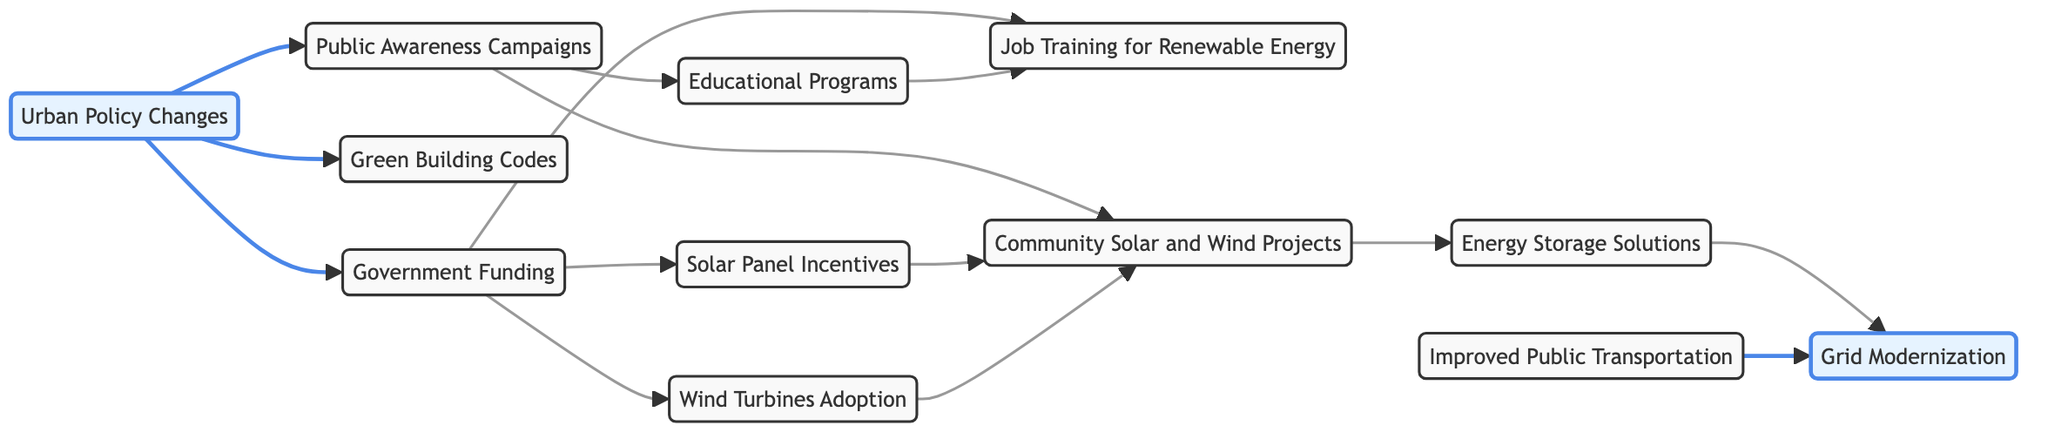What are the primary nodes in the diagram? The primary nodes are the main concepts linked within the directed graph. In this case, they include Urban Policy Changes, Public Awareness Campaigns, Solar Panel Incentives, Wind Turbines Adoption, Green Building Codes, Government Funding, Educational Programs, Job Training for Renewable Energy, Community Solar and Wind Projects, Improved Public Transportation, Energy Storage Solutions, and Grid Modernization.
Answer: Urban Policy Changes, Public Awareness Campaigns, Solar Panel Incentives, Wind Turbines Adoption, Green Building Codes, Government Funding, Educational Programs, Job Training for Renewable Energy, Community Solar and Wind Projects, Improved Public Transportation, Energy Storage Solutions, Grid Modernization How many edges are present in the graph? Edges in a directed graph are the connections between nodes. By counting each connection shown, the total number of edges in this diagram comes out to 13.
Answer: 13 Which node is influenced directly by Urban Policy Changes? Urban Policy Changes directly influences three other nodes in the graph: Public Awareness Campaigns, Green Building Codes, and Government Funding. To find the answer, we look for the nodes that are connected with an outgoing arrow from Urban Policy Changes.
Answer: Public Awareness, Green Building, Funding How does Community Projects lead to Grid Modernization? Community Projects influences Energy Storage Solutions, which in turn leads to Grid Modernization. To trace this pathway, we note the directed connections starting from Community Projects -> Energy Storage -> Grid Modernization.
Answer: Energy Storage What is the relationship between Funding and Solar Panel Incentives? Funding influences Solar Panel Incentives directly, meaning there is a direct edge connecting these two nodes. We can see that the arrow goes from the node Funding to Solar Panel Incentives, establishing this relationship clearly.
Answer: Direct How many nodes are influenced by Public Awareness Campaigns? Public Awareness Campaigns influences two nodes directly: Educational Programs and Community Projects. By counting the respective outgoing edges from Public Awareness Campaigns in the diagram, we find there are two connections.
Answer: 2 Which nodes are interconnected through Job Training? Job Training is influenced by two nodes: Funding (which provides resources for Job Training) and Educational Programs (which prepare individuals for Jobs in Renewable Energy). Therefore, both nodes point towards Job Training in the directed graph.
Answer: Funding, Educational Programs What is the final outcome chain starting from Urban Policy Changes to Grid Modernization? Starting from Urban Policy Changes, the flow moves to: Public Awareness, which then branches out to Educational Programs and Community Projects. Funding derives from Urban Policy Changes too, leading to Solar Panel Incentives and Wind Turbines. Meanwhile, Community Projects influence Energy Storage Solutions, ultimately leading to Grid Modernization. Following the chain accurately gives us this sequence: Urban Policy Changes -> Public Awareness -> Community Projects -> Energy Storage -> Grid Modernization.
Answer: Urban Policy Changes → Public Awareness → Community Projects → Energy Storage → Grid Modernization In which segment does Improved Public Transportation influence the graph? Improved Public Transportation connects directly to Grid Modernization, indicating that enhancements in public transport are a contributor to modernizing the energy grid. We identify this connection by locating the direct edge leading from Improved Public Transportation to Grid Modernization.
Answer: Grid Modernization 